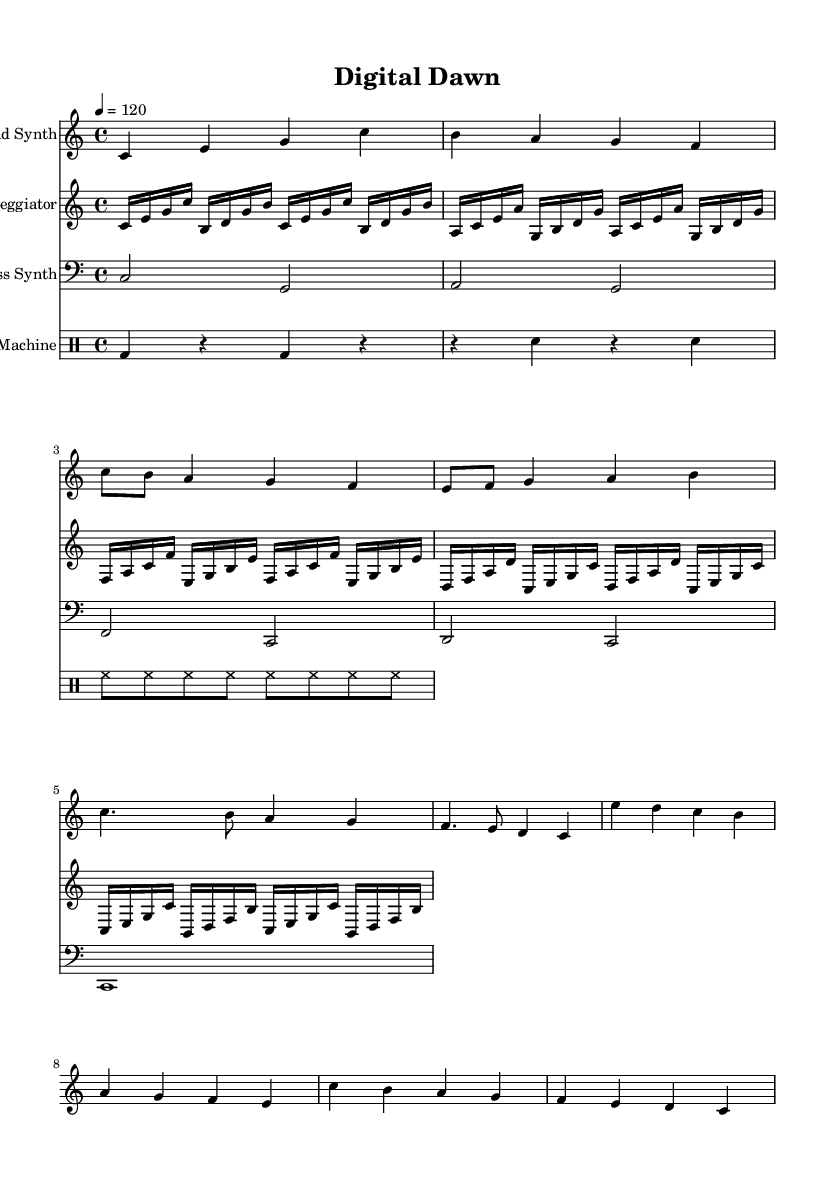What is the key signature of this music? The key signature is C major, which has no sharps or flats.
Answer: C major What is the time signature of this music? The time signature is indicated as 4/4, which means there are four beats in a measure and the quarter note receives one beat.
Answer: 4/4 What is the tempo marking of this piece? The tempo marking is set at 4 beats per minute = 120, indicating the speed of the music.
Answer: 120 How many measures are in the chorus section? The chorus consists of 4 measures, based on the corresponding section of the sheet music.
Answer: 4 What instrument plays the lead melody? The lead melody is played by the Lead Synth as indicated in the staff instrument name.
Answer: Lead Synth Which instrument has the clef marked as bass? The Bass Synth has the clef marked as bass, indicating its lower register playing range.
Answer: Bass Synth What rhythmic pattern is used for the hi-hat in the drum machine section? The hi-hat plays a consistent eighth-note pattern throughout, as represented by the notation.
Answer: Eighth notes 